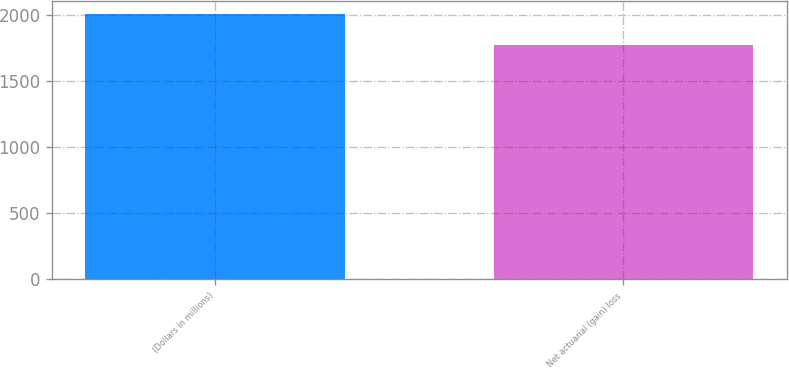<chart> <loc_0><loc_0><loc_500><loc_500><bar_chart><fcel>(Dollars in millions)<fcel>Net actuarial (gain) loss<nl><fcel>2007<fcel>1776<nl></chart> 